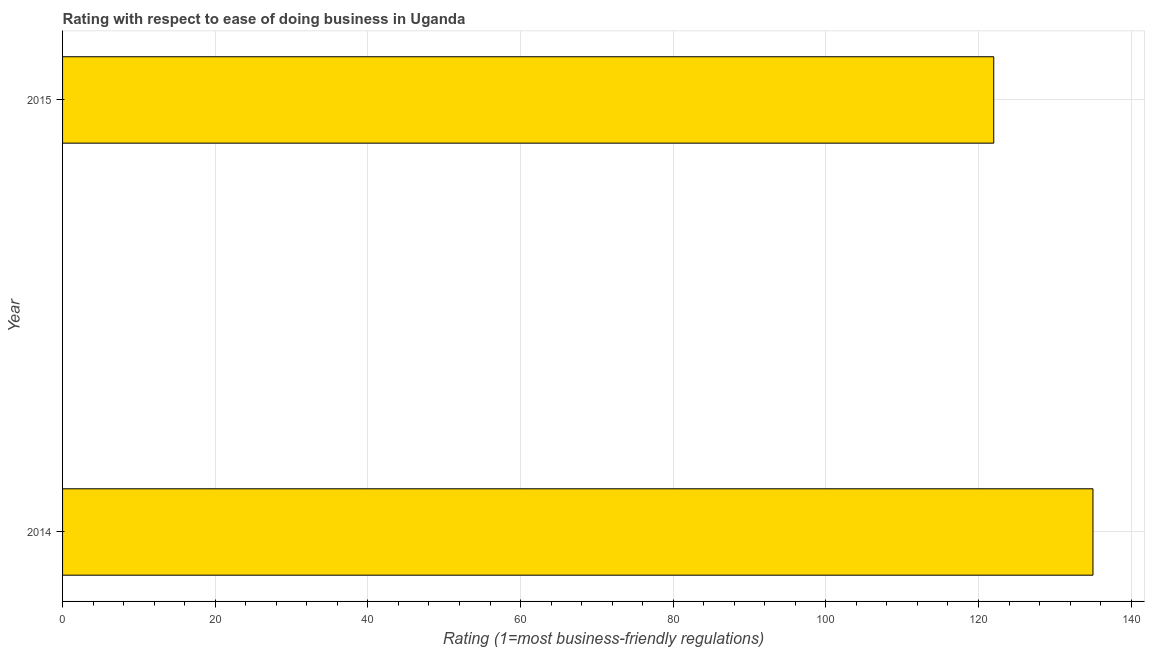Does the graph contain grids?
Your response must be concise. Yes. What is the title of the graph?
Your response must be concise. Rating with respect to ease of doing business in Uganda. What is the label or title of the X-axis?
Offer a terse response. Rating (1=most business-friendly regulations). What is the ease of doing business index in 2014?
Give a very brief answer. 135. Across all years, what is the maximum ease of doing business index?
Provide a succinct answer. 135. Across all years, what is the minimum ease of doing business index?
Provide a succinct answer. 122. In which year was the ease of doing business index minimum?
Your answer should be very brief. 2015. What is the sum of the ease of doing business index?
Keep it short and to the point. 257. What is the average ease of doing business index per year?
Make the answer very short. 128. What is the median ease of doing business index?
Your answer should be very brief. 128.5. In how many years, is the ease of doing business index greater than 120 ?
Offer a very short reply. 2. What is the ratio of the ease of doing business index in 2014 to that in 2015?
Your answer should be compact. 1.11. What is the Rating (1=most business-friendly regulations) of 2014?
Provide a short and direct response. 135. What is the Rating (1=most business-friendly regulations) in 2015?
Offer a very short reply. 122. What is the difference between the Rating (1=most business-friendly regulations) in 2014 and 2015?
Your answer should be very brief. 13. What is the ratio of the Rating (1=most business-friendly regulations) in 2014 to that in 2015?
Make the answer very short. 1.11. 